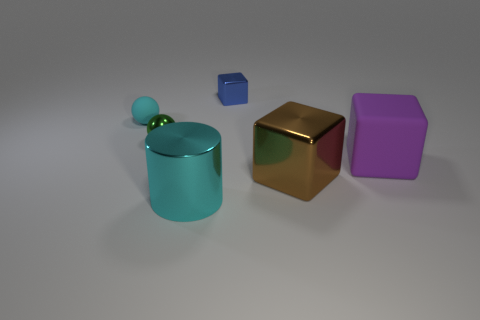Subtract 1 cubes. How many cubes are left? 2 Add 2 large brown blocks. How many objects exist? 8 Subtract all big cubes. How many cubes are left? 1 Subtract all balls. How many objects are left? 4 Subtract all tiny red objects. Subtract all large brown blocks. How many objects are left? 5 Add 3 big brown objects. How many big brown objects are left? 4 Add 5 large purple metallic cylinders. How many large purple metallic cylinders exist? 5 Subtract 0 brown spheres. How many objects are left? 6 